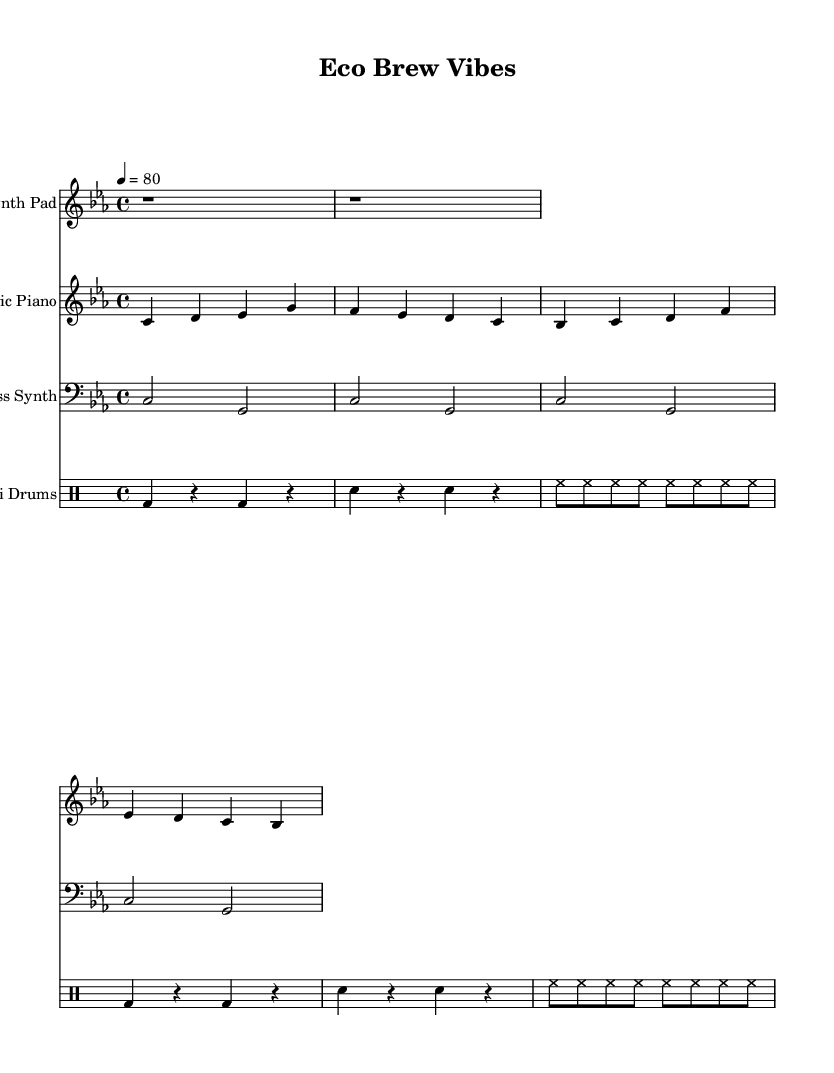What is the key signature of this music? The key signature is C minor, which consists of three flats (B♭, E♭, A♭). It can be identified in the initial part of the sheet music, where the key is indicated.
Answer: C minor What is the time signature of this music? The time signature is 4/4, which indicates four beats in a measure (bar) and that the quarter note gets one beat. This can be seen at the beginning of the sheet music, right after the key signature.
Answer: 4/4 What is the tempo marking of this piece? The tempo marking is 80 beats per minute, indicated in the score at the beginning (4 = 80). This shows the intended speed at which the piece should be played.
Answer: 80 How many measures are in the electric piano part? The electric piano part contains a total of 4 measures, which can be counted visually in the notation provided. Each distinct grouping of notes divided by vertical lines represents a measure.
Answer: 4 What type of drums are used in the drums part? The drums part primarily uses bass drum (bd), snare drum (sn), and hi-hat (hh) notations. Each is represented in the drum mode section of the score, showing the standard elements for a lo-fi beats setup.
Answer: Bass, snare, hi-hat Which instrument plays the bass line? The bass line is played by a Bass Synth, as indicated in the instrument names at the beginning of the staff. This identifies which voice is responsible for the bass part in the arrangement.
Answer: Bass Synth How many notes are in the first measure of the electric piano part? The first measure of the electric piano part contains 4 notes (C, D, E♭, G). Each note corresponds to the rhythmic placement in that measure, totaling to four distinct sounds.
Answer: 4 